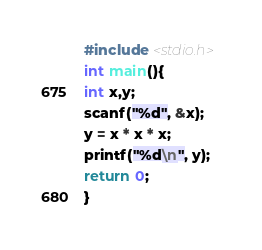<code> <loc_0><loc_0><loc_500><loc_500><_C_>#include <stdio.h>
int main(){
int x,y;
scanf("%d", &x);
y = x * x * x;
printf("%d\n", y);
return 0;
}
</code> 